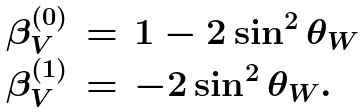<formula> <loc_0><loc_0><loc_500><loc_500>\begin{array} { r c l } \beta _ { V } ^ { ( 0 ) } & = & 1 - 2 \sin ^ { 2 } \theta _ { W } \\ \beta _ { V } ^ { ( 1 ) } & = & - 2 \sin ^ { 2 } \theta _ { W } . \end{array}</formula> 